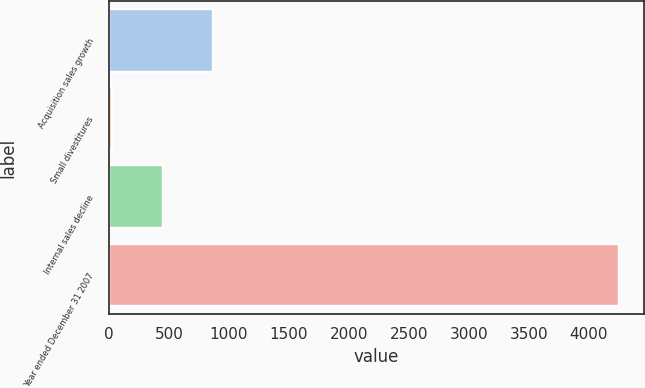Convert chart to OTSL. <chart><loc_0><loc_0><loc_500><loc_500><bar_chart><fcel>Acquisition sales growth<fcel>Small divestitures<fcel>Internal sales decline<fcel>Year ended December 31 2007<nl><fcel>871.6<fcel>27<fcel>449.3<fcel>4250<nl></chart> 